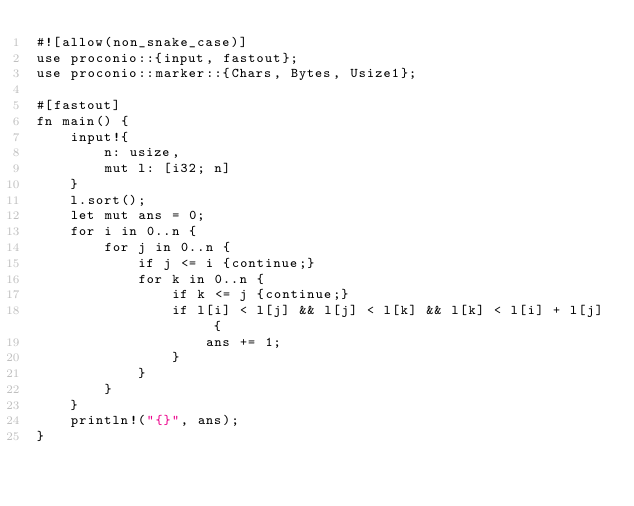<code> <loc_0><loc_0><loc_500><loc_500><_Rust_>#![allow(non_snake_case)]
use proconio::{input, fastout};
use proconio::marker::{Chars, Bytes, Usize1};

#[fastout]
fn main() {
    input!{
        n: usize,
        mut l: [i32; n]
    }
    l.sort();
    let mut ans = 0;
    for i in 0..n {
        for j in 0..n {
            if j <= i {continue;}
            for k in 0..n {
                if k <= j {continue;}
                if l[i] < l[j] && l[j] < l[k] && l[k] < l[i] + l[j] {
                    ans += 1;
                }
            }
        }
    }
    println!("{}", ans);
}
</code> 